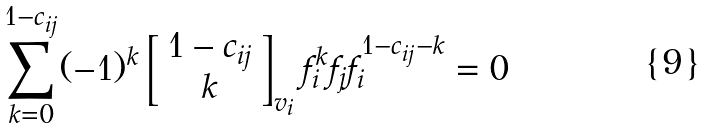<formula> <loc_0><loc_0><loc_500><loc_500>\sum _ { k = 0 } ^ { 1 - c _ { i j } } ( - 1 ) ^ { k } \left [ \begin{array} { c } 1 - c _ { i j } \\ k \end{array} \right ] _ { v _ { i } } f _ { i } ^ { k } f _ { j } f _ { i } ^ { 1 - c _ { i j } - k } = 0</formula> 